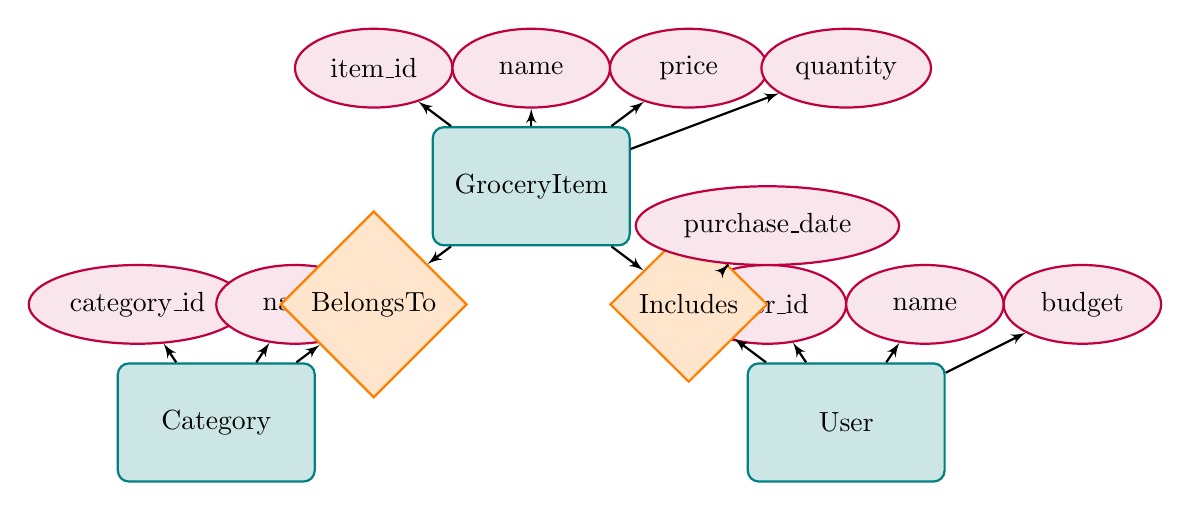What is the name of the entity that represents grocery items? The diagram shows an entity named "GroceryItem" which is clearly labeled at the top.
Answer: GroceryItem How many attributes does the User entity have? The User entity is connected to three attributes: user_id, name, and budget, which can be counted.
Answer: 3 What relationship exists between GroceryItem and Category? The diagram indicates a "BelongsTo" relationship connecting GroceryItem and Category entities.
Answer: BelongsTo What is the attribute associated with the Includes relationship? The Includes relationship is connected to the attribute named "purchase_date," which is specifically indicated in the diagram.
Answer: purchase_date What primary attribute identifies the Category entity? The Category entity has an attribute labeled "category_id," illustrating its primary identifier.
Answer: category_id How many entities are in the diagram? Analyze the diagram and count the entities displayed: GroceryItem, Category, and User, leading to a total count.
Answer: 3 Which entity has a budget attribute? By examining the attributes of the User entity, which includes budget, we can determine the entity related to budget allocation.
Answer: User What is the relationship that connects User to GroceryItem? The diagram illustrates an "Includes" relationship that connects the User entity directly to the GroceryItem entity.
Answer: Includes Which entity has a price attribute? The GroceryItem entity is shown to include an attribute labeled "price," identifying it as the entity with this attribute.
Answer: GroceryItem 